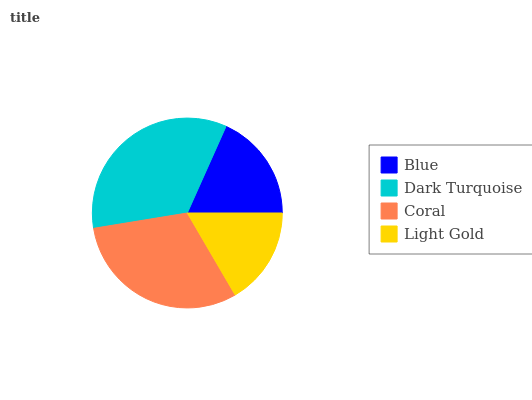Is Light Gold the minimum?
Answer yes or no. Yes. Is Dark Turquoise the maximum?
Answer yes or no. Yes. Is Coral the minimum?
Answer yes or no. No. Is Coral the maximum?
Answer yes or no. No. Is Dark Turquoise greater than Coral?
Answer yes or no. Yes. Is Coral less than Dark Turquoise?
Answer yes or no. Yes. Is Coral greater than Dark Turquoise?
Answer yes or no. No. Is Dark Turquoise less than Coral?
Answer yes or no. No. Is Coral the high median?
Answer yes or no. Yes. Is Blue the low median?
Answer yes or no. Yes. Is Dark Turquoise the high median?
Answer yes or no. No. Is Coral the low median?
Answer yes or no. No. 